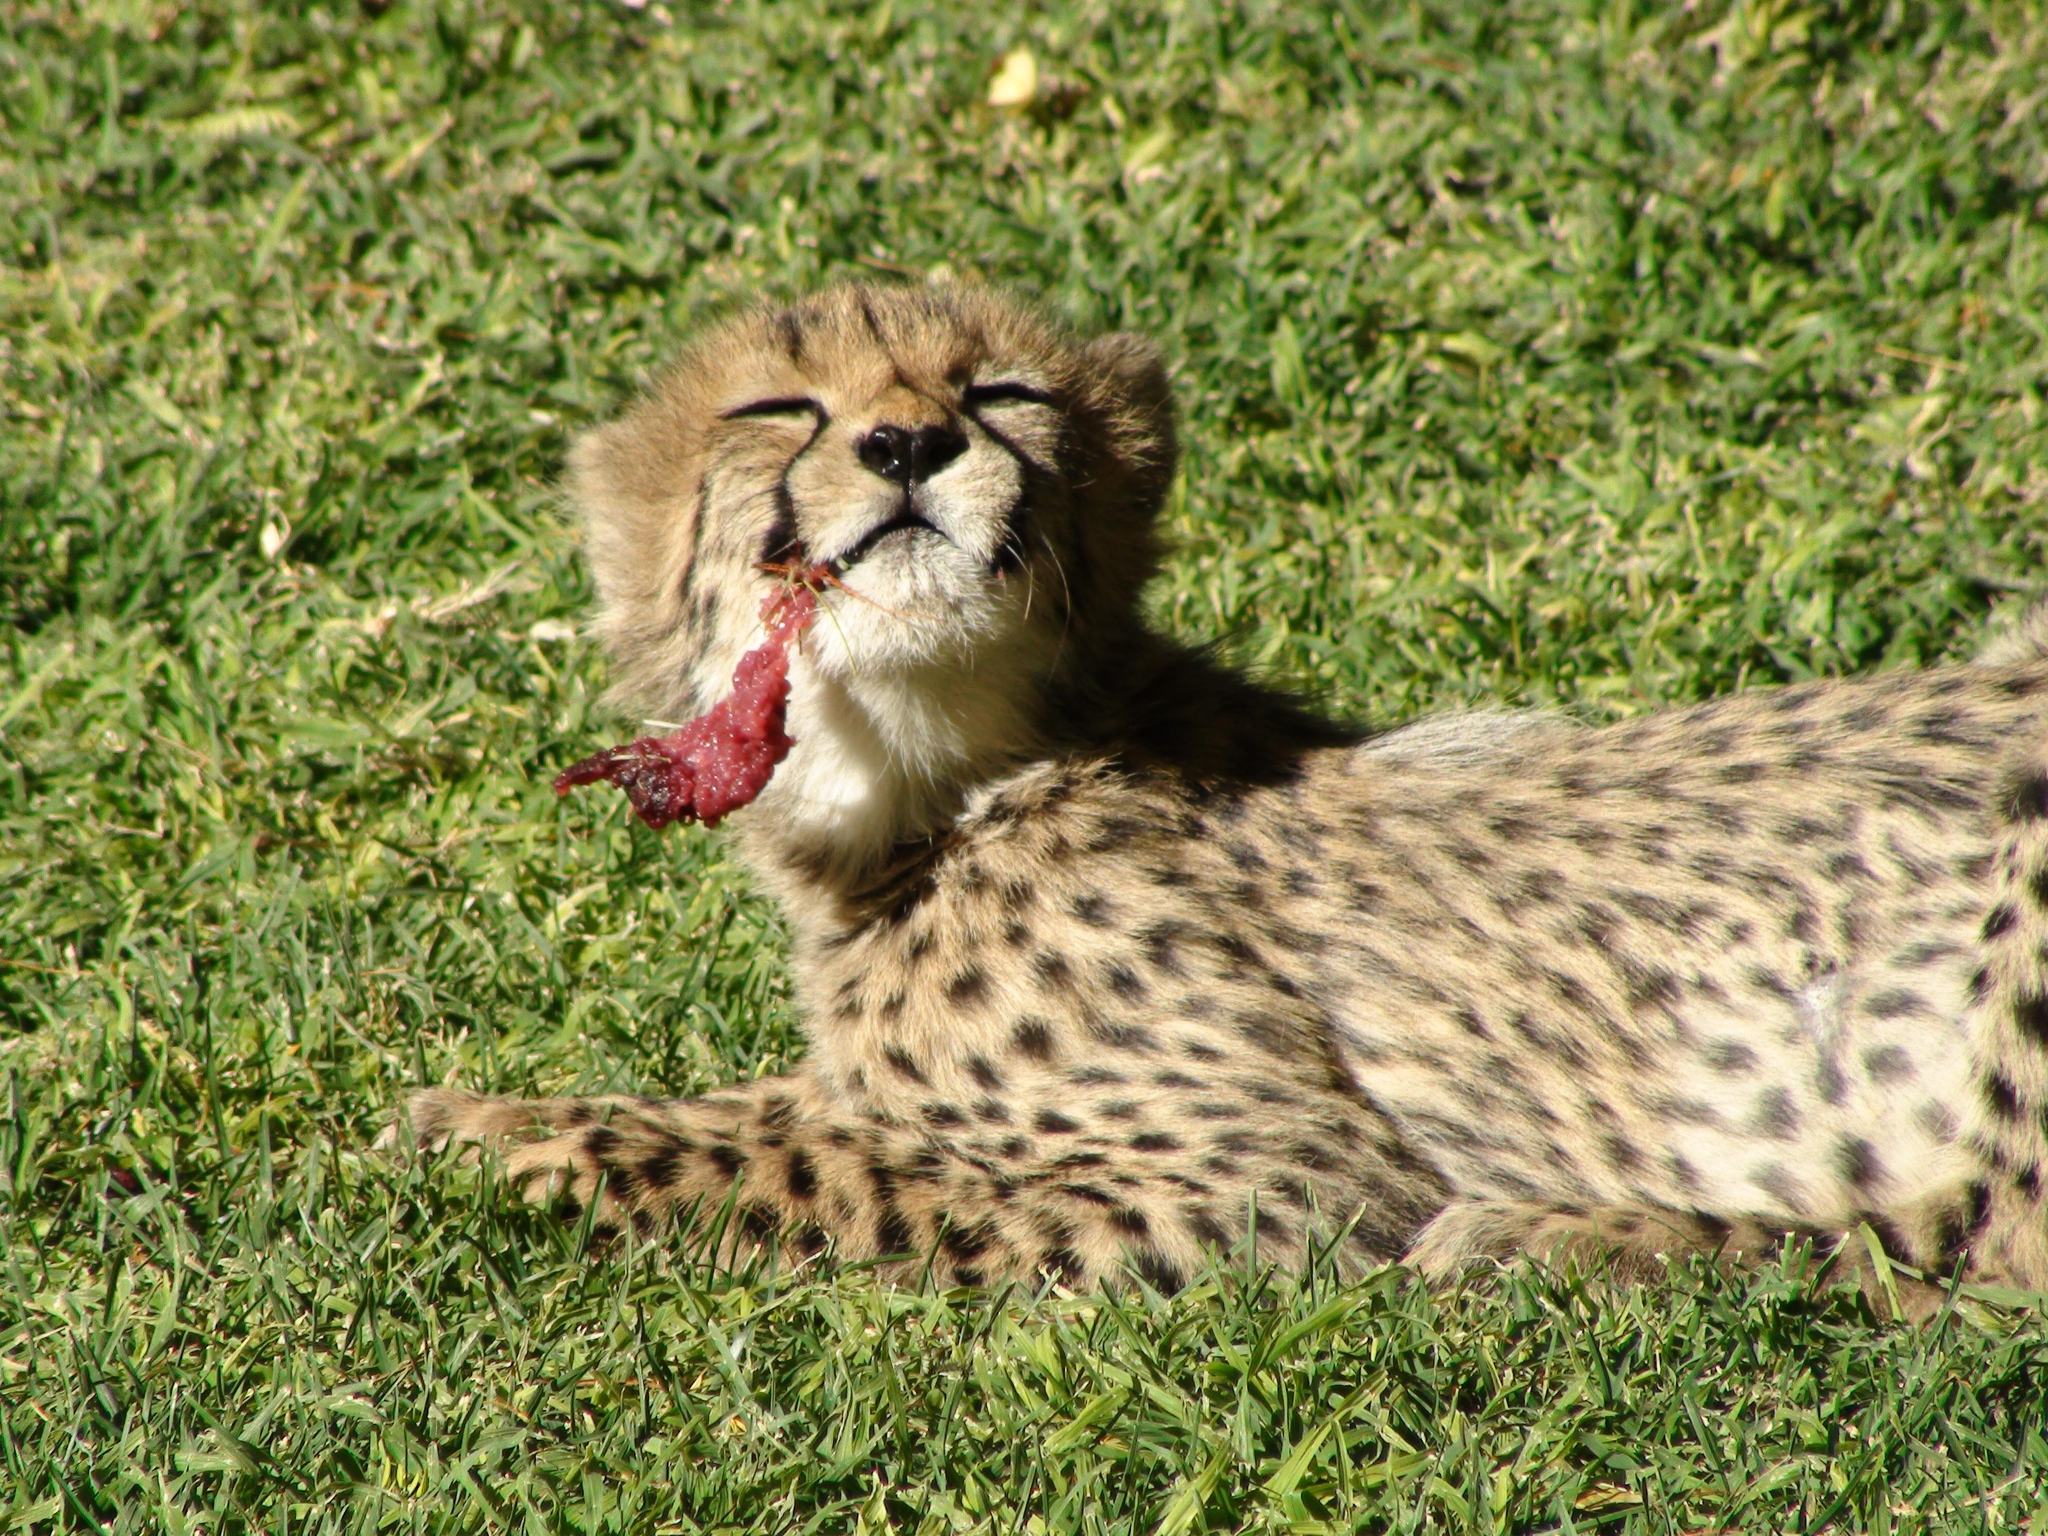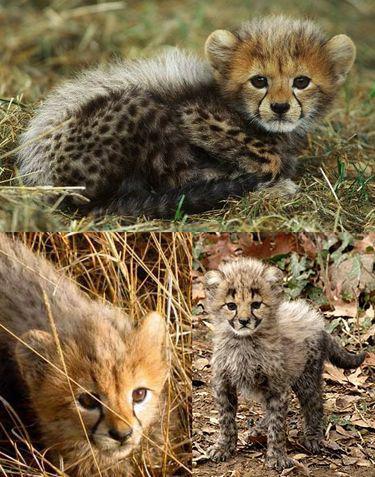The first image is the image on the left, the second image is the image on the right. For the images displayed, is the sentence "In one of the images a cheetah can be seen with meat in its mouth." factually correct? Answer yes or no. Yes. The first image is the image on the left, the second image is the image on the right. Given the left and right images, does the statement "There are leopards and at least one deer." hold true? Answer yes or no. No. 